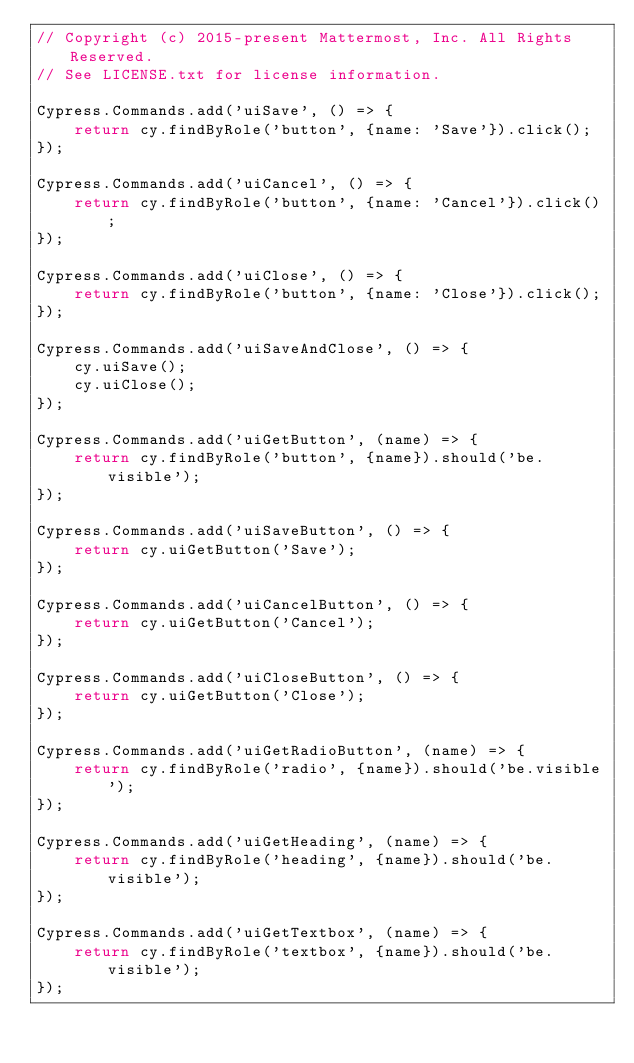<code> <loc_0><loc_0><loc_500><loc_500><_JavaScript_>// Copyright (c) 2015-present Mattermost, Inc. All Rights Reserved.
// See LICENSE.txt for license information.

Cypress.Commands.add('uiSave', () => {
    return cy.findByRole('button', {name: 'Save'}).click();
});

Cypress.Commands.add('uiCancel', () => {
    return cy.findByRole('button', {name: 'Cancel'}).click();
});

Cypress.Commands.add('uiClose', () => {
    return cy.findByRole('button', {name: 'Close'}).click();
});

Cypress.Commands.add('uiSaveAndClose', () => {
    cy.uiSave();
    cy.uiClose();
});

Cypress.Commands.add('uiGetButton', (name) => {
    return cy.findByRole('button', {name}).should('be.visible');
});

Cypress.Commands.add('uiSaveButton', () => {
    return cy.uiGetButton('Save');
});

Cypress.Commands.add('uiCancelButton', () => {
    return cy.uiGetButton('Cancel');
});

Cypress.Commands.add('uiCloseButton', () => {
    return cy.uiGetButton('Close');
});

Cypress.Commands.add('uiGetRadioButton', (name) => {
    return cy.findByRole('radio', {name}).should('be.visible');
});

Cypress.Commands.add('uiGetHeading', (name) => {
    return cy.findByRole('heading', {name}).should('be.visible');
});

Cypress.Commands.add('uiGetTextbox', (name) => {
    return cy.findByRole('textbox', {name}).should('be.visible');
});
</code> 